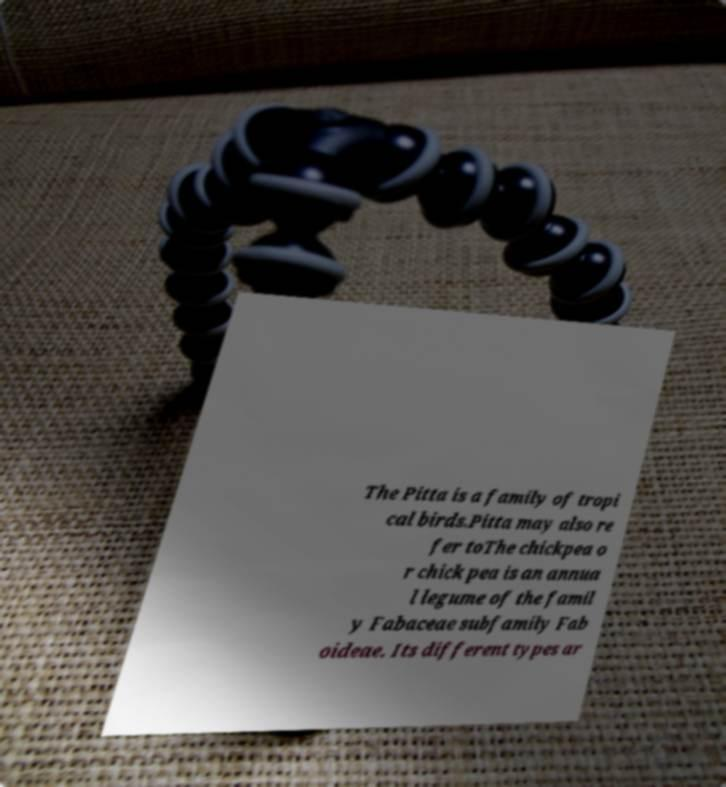Can you read and provide the text displayed in the image?This photo seems to have some interesting text. Can you extract and type it out for me? The Pitta is a family of tropi cal birds.Pitta may also re fer toThe chickpea o r chick pea is an annua l legume of the famil y Fabaceae subfamily Fab oideae. Its different types ar 